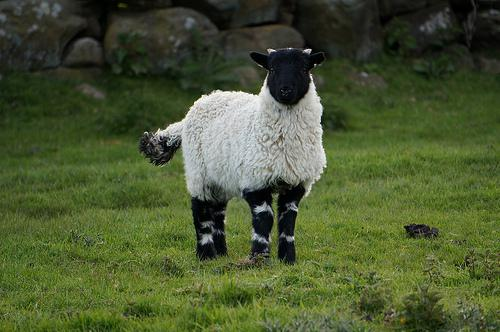Question: what animal is this?
Choices:
A. Bear.
B. Dog.
C. Goat.
D. Rabbit.
Answer with the letter. Answer: C Question: where was this taken?
Choices:
A. In the supermarket.
B. At the beach.
C. In an office.
D. Grassy field.
Answer with the letter. Answer: D Question: what is this shot of?
Choices:
A. A basketball player.
B. A refrigerator.
C. Lone goat.
D. A mailbox.
Answer with the letter. Answer: C Question: how many goats are there?
Choices:
A. 2.
B. 3.
C. 4.
D. 1.
Answer with the letter. Answer: D 